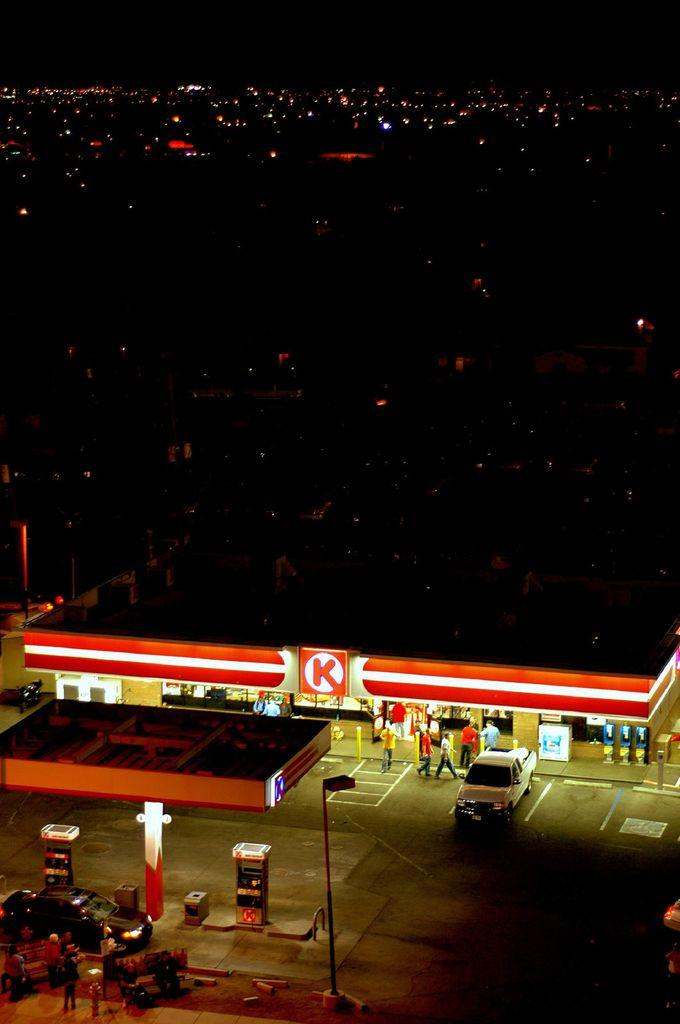<image>
Present a compact description of the photo's key features. A gas station with a car outside labeled with a "K" on the front. 